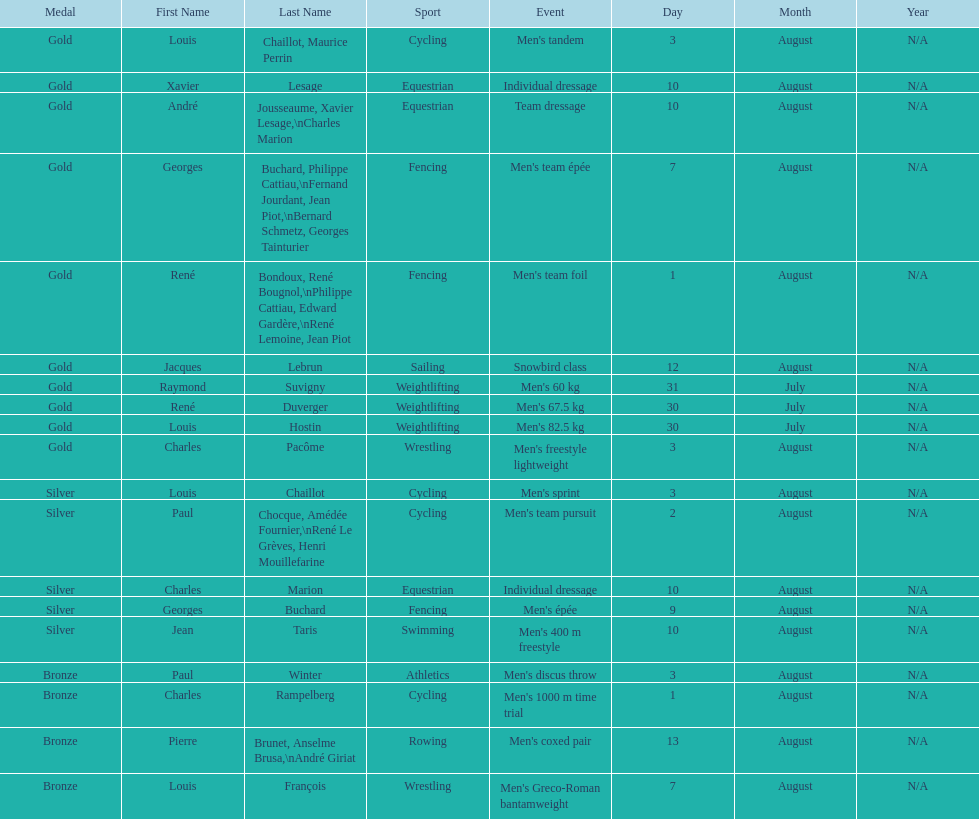What is next date that is listed after august 7th? August 1. 